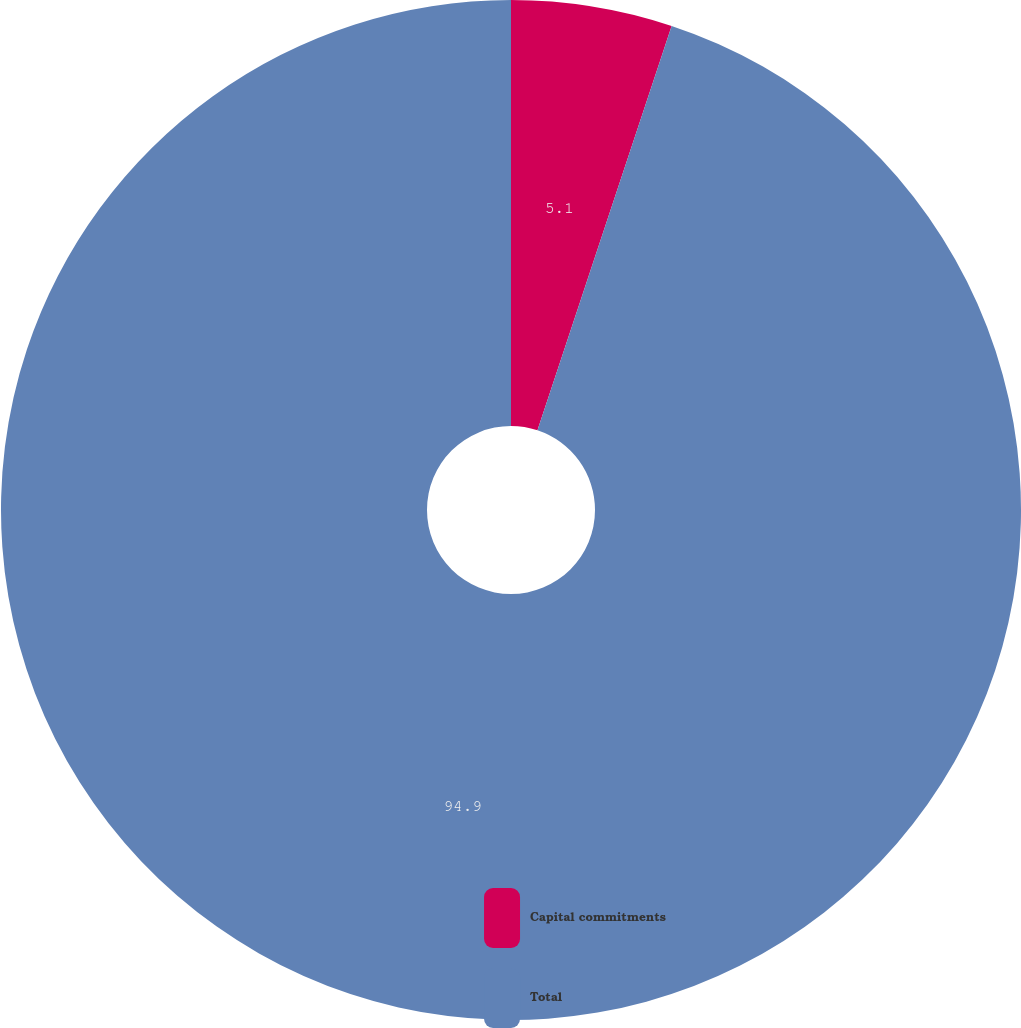Convert chart to OTSL. <chart><loc_0><loc_0><loc_500><loc_500><pie_chart><fcel>Capital commitments<fcel>Total<nl><fcel>5.1%<fcel>94.9%<nl></chart> 